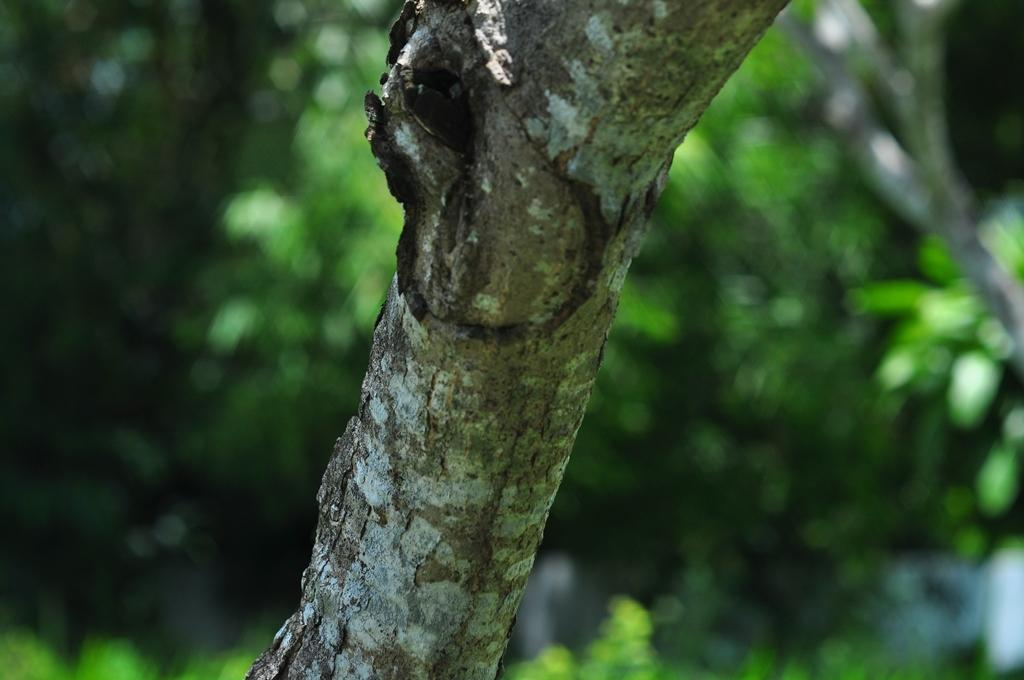What is the main subject of the image? The main subject of the image is a branch of a tree. Can you describe the background of the image? In the background of the image, there is a group of trees. What type of fire can be seen in the image? There is no fire present in the image; it features a branch of a tree and a group of trees in the background. 